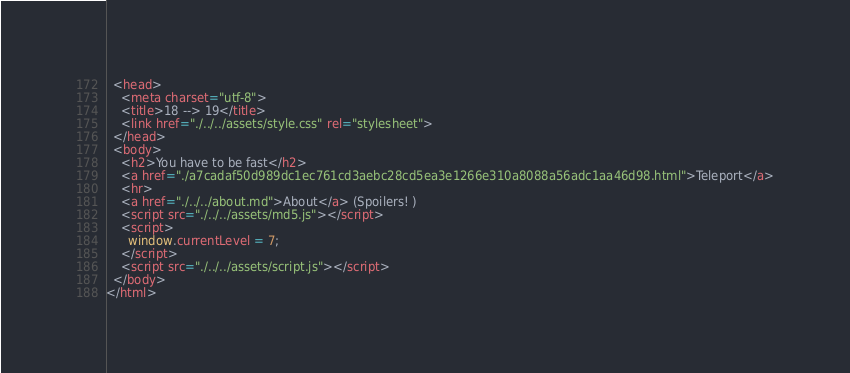Convert code to text. <code><loc_0><loc_0><loc_500><loc_500><_HTML_>  <head>
    <meta charset="utf-8">
    <title>18 --> 19</title>
    <link href="./../../assets/style.css" rel="stylesheet">
  </head>
  <body>
    <h2>You have to be fast</h2>
    <a href="./a7cadaf50d989dc1ec761cd3aebc28cd5ea3e1266e310a8088a56adc1aa46d98.html">Teleport</a>
    <hr>
    <a href="./../../about.md">About</a> (Spoilers! )
    <script src="./../../assets/md5.js"></script>
    <script>
      window.currentLevel = 7;
    </script>
    <script src="./../../assets/script.js"></script>
  </body>
</html></code> 